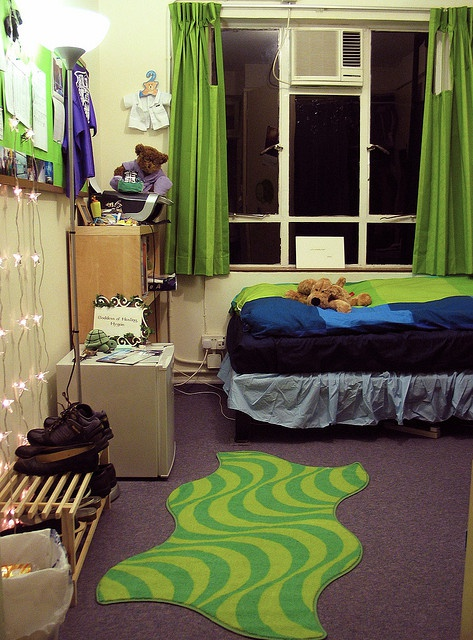Describe the objects in this image and their specific colors. I can see bed in lightgreen, black, gray, navy, and darkgray tones, refrigerator in lightgreen, gray, and beige tones, and teddy bear in lightgreen, maroon, gray, black, and darkgray tones in this image. 